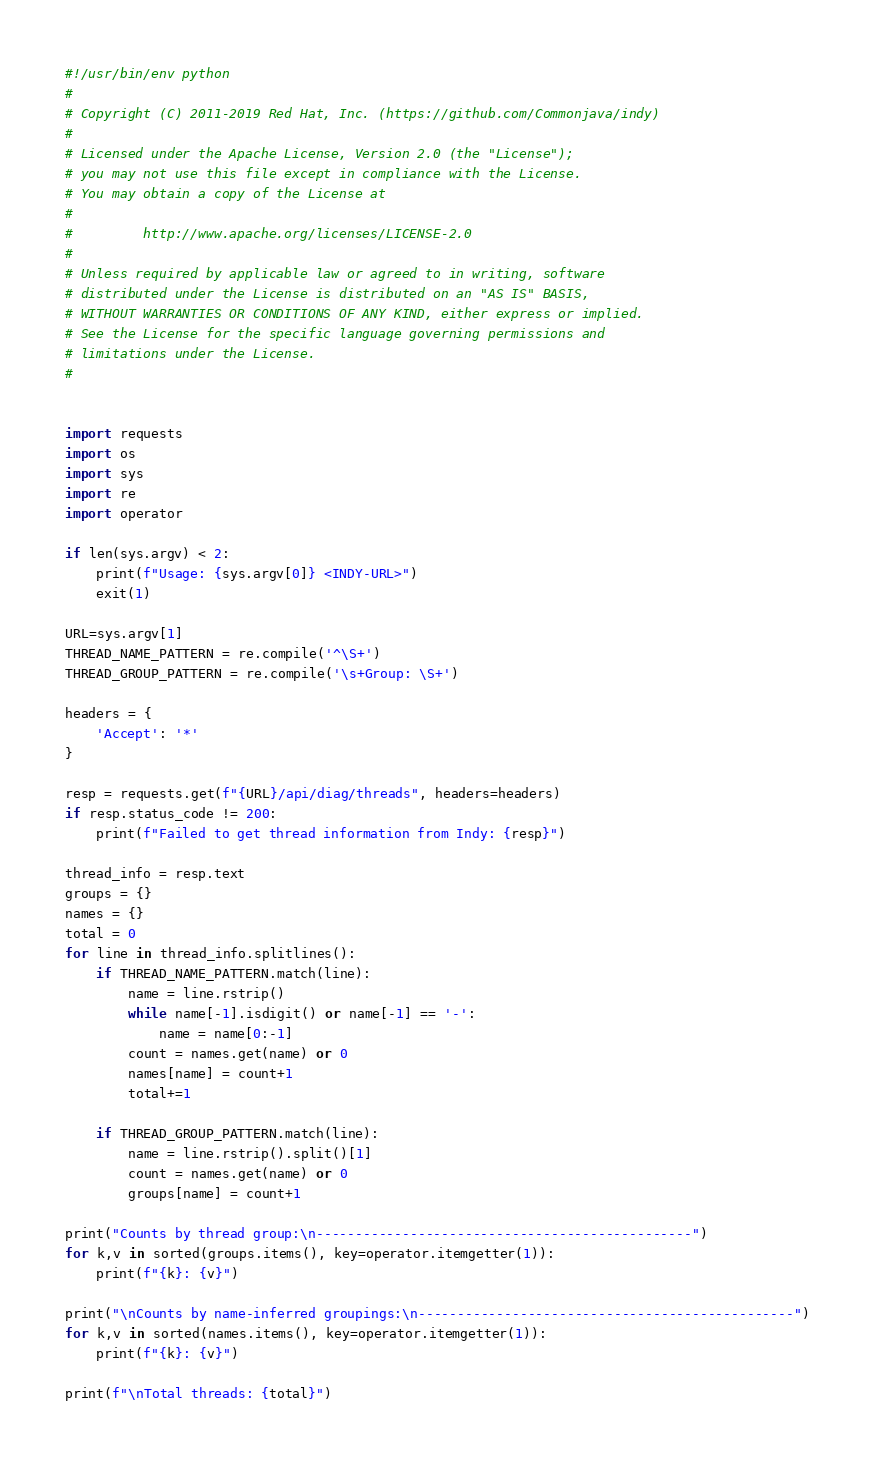<code> <loc_0><loc_0><loc_500><loc_500><_Python_>#!/usr/bin/env python
#
# Copyright (C) 2011-2019 Red Hat, Inc. (https://github.com/Commonjava/indy)
#
# Licensed under the Apache License, Version 2.0 (the "License");
# you may not use this file except in compliance with the License.
# You may obtain a copy of the License at
#
#         http://www.apache.org/licenses/LICENSE-2.0
#
# Unless required by applicable law or agreed to in writing, software
# distributed under the License is distributed on an "AS IS" BASIS,
# WITHOUT WARRANTIES OR CONDITIONS OF ANY KIND, either express or implied.
# See the License for the specific language governing permissions and
# limitations under the License.
#


import requests
import os
import sys
import re
import operator

if len(sys.argv) < 2:
	print(f"Usage: {sys.argv[0]} <INDY-URL>")
	exit(1)

URL=sys.argv[1]
THREAD_NAME_PATTERN = re.compile('^\S+')
THREAD_GROUP_PATTERN = re.compile('\s+Group: \S+')

headers = {
	'Accept': '*'
}

resp = requests.get(f"{URL}/api/diag/threads", headers=headers)
if resp.status_code != 200:
	print(f"Failed to get thread information from Indy: {resp}")

thread_info = resp.text
groups = {}
names = {}
total = 0
for line in thread_info.splitlines():
	if THREAD_NAME_PATTERN.match(line):
		name = line.rstrip()
		while name[-1].isdigit() or name[-1] == '-':
			name = name[0:-1]
		count = names.get(name) or 0
		names[name] = count+1
		total+=1

	if THREAD_GROUP_PATTERN.match(line):
		name = line.rstrip().split()[1]
		count = names.get(name) or 0
		groups[name] = count+1

print("Counts by thread group:\n------------------------------------------------")
for k,v in sorted(groups.items(), key=operator.itemgetter(1)):
	print(f"{k}: {v}")

print("\nCounts by name-inferred groupings:\n------------------------------------------------")
for k,v in sorted(names.items(), key=operator.itemgetter(1)):
	print(f"{k}: {v}")

print(f"\nTotal threads: {total}")

</code> 